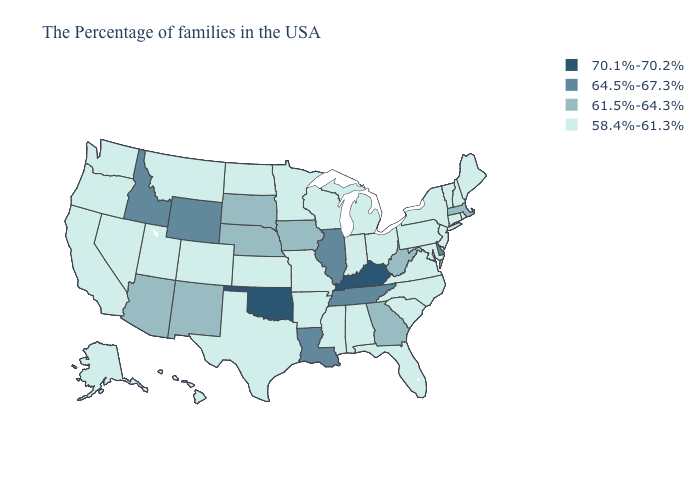Name the states that have a value in the range 70.1%-70.2%?
Short answer required. Kentucky, Oklahoma. Which states hav the highest value in the Northeast?
Answer briefly. Massachusetts. Does the first symbol in the legend represent the smallest category?
Write a very short answer. No. Does Arizona have the lowest value in the USA?
Be succinct. No. What is the highest value in states that border New York?
Concise answer only. 61.5%-64.3%. Does Arizona have a lower value than New Hampshire?
Give a very brief answer. No. Does Kentucky have the same value as Oklahoma?
Give a very brief answer. Yes. Does the map have missing data?
Give a very brief answer. No. Does North Dakota have the highest value in the USA?
Short answer required. No. Which states have the highest value in the USA?
Write a very short answer. Kentucky, Oklahoma. Among the states that border Tennessee , does Kentucky have the highest value?
Answer briefly. Yes. Name the states that have a value in the range 58.4%-61.3%?
Write a very short answer. Maine, Rhode Island, New Hampshire, Vermont, Connecticut, New York, New Jersey, Maryland, Pennsylvania, Virginia, North Carolina, South Carolina, Ohio, Florida, Michigan, Indiana, Alabama, Wisconsin, Mississippi, Missouri, Arkansas, Minnesota, Kansas, Texas, North Dakota, Colorado, Utah, Montana, Nevada, California, Washington, Oregon, Alaska, Hawaii. Name the states that have a value in the range 58.4%-61.3%?
Give a very brief answer. Maine, Rhode Island, New Hampshire, Vermont, Connecticut, New York, New Jersey, Maryland, Pennsylvania, Virginia, North Carolina, South Carolina, Ohio, Florida, Michigan, Indiana, Alabama, Wisconsin, Mississippi, Missouri, Arkansas, Minnesota, Kansas, Texas, North Dakota, Colorado, Utah, Montana, Nevada, California, Washington, Oregon, Alaska, Hawaii. Among the states that border Delaware , which have the highest value?
Keep it brief. New Jersey, Maryland, Pennsylvania. Is the legend a continuous bar?
Quick response, please. No. 